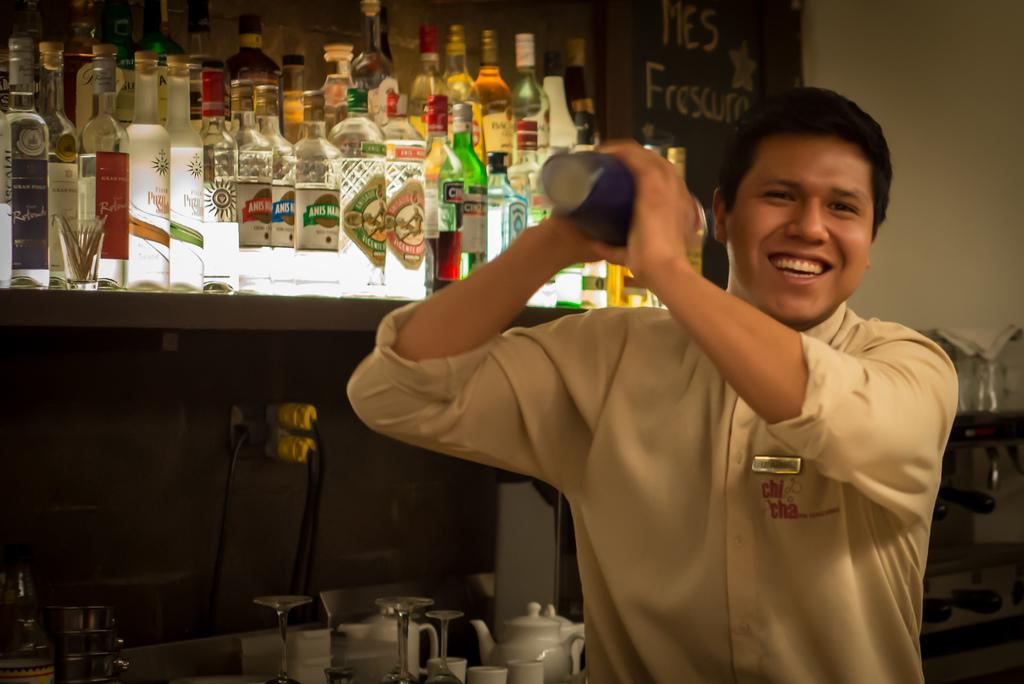What is the person in the image doing? The person is standing in the image and holding a bottle. What else can be seen in the image besides the person? There is a wall visible in the image, as well as bottles, a kettle, glasses, and cups. How many bottles are present in the image? There are bottles in the image, but the exact number is not specified. What might the person be using the bottle for? The person might be using the bottle to pour a liquid into the kettle, glasses, or cups. What type of powder is being used to make the person's sweater in the image? There is no sweater or powder present in the image. What type of voyage is the person embarking on in the image? There is no indication of a voyage in the image; the person is simply standing and holding a bottle. 